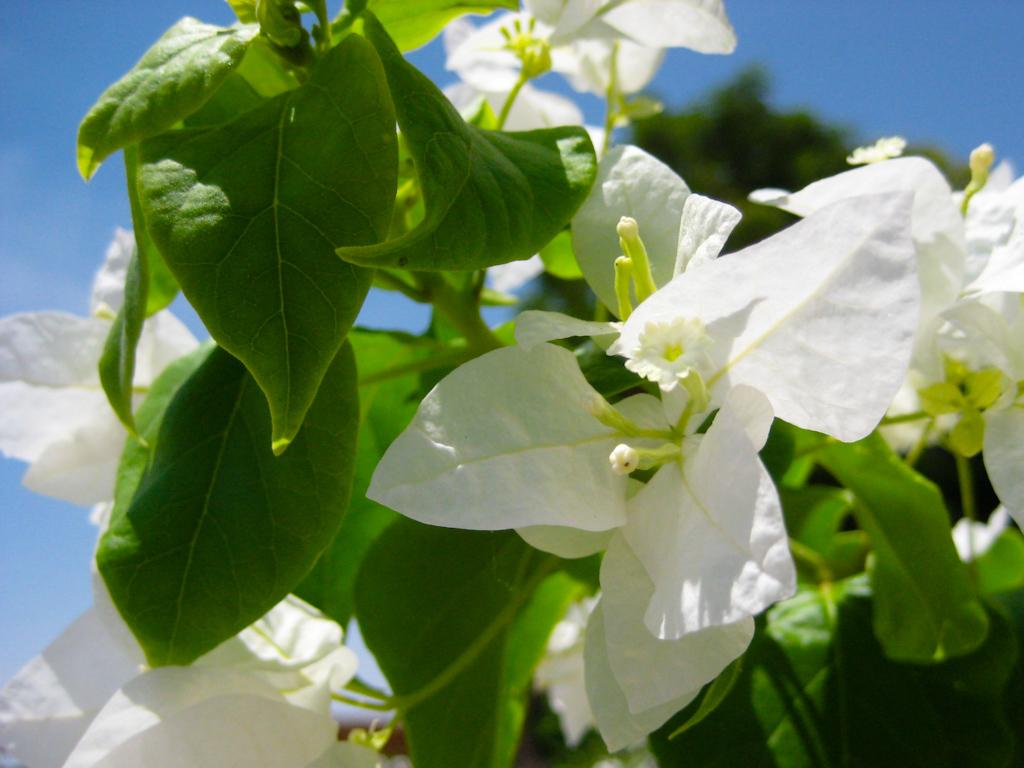What color are the flowers on the plant in the image? The flowers on the plant are white-colored. What is the condition of the sky in the image? The sky is clear in the image. How would you describe the background of the image? The background of the image is slightly blurred. What month is it in the image? The month cannot be determined from the image, as there is no information about the time of year or specific date. 